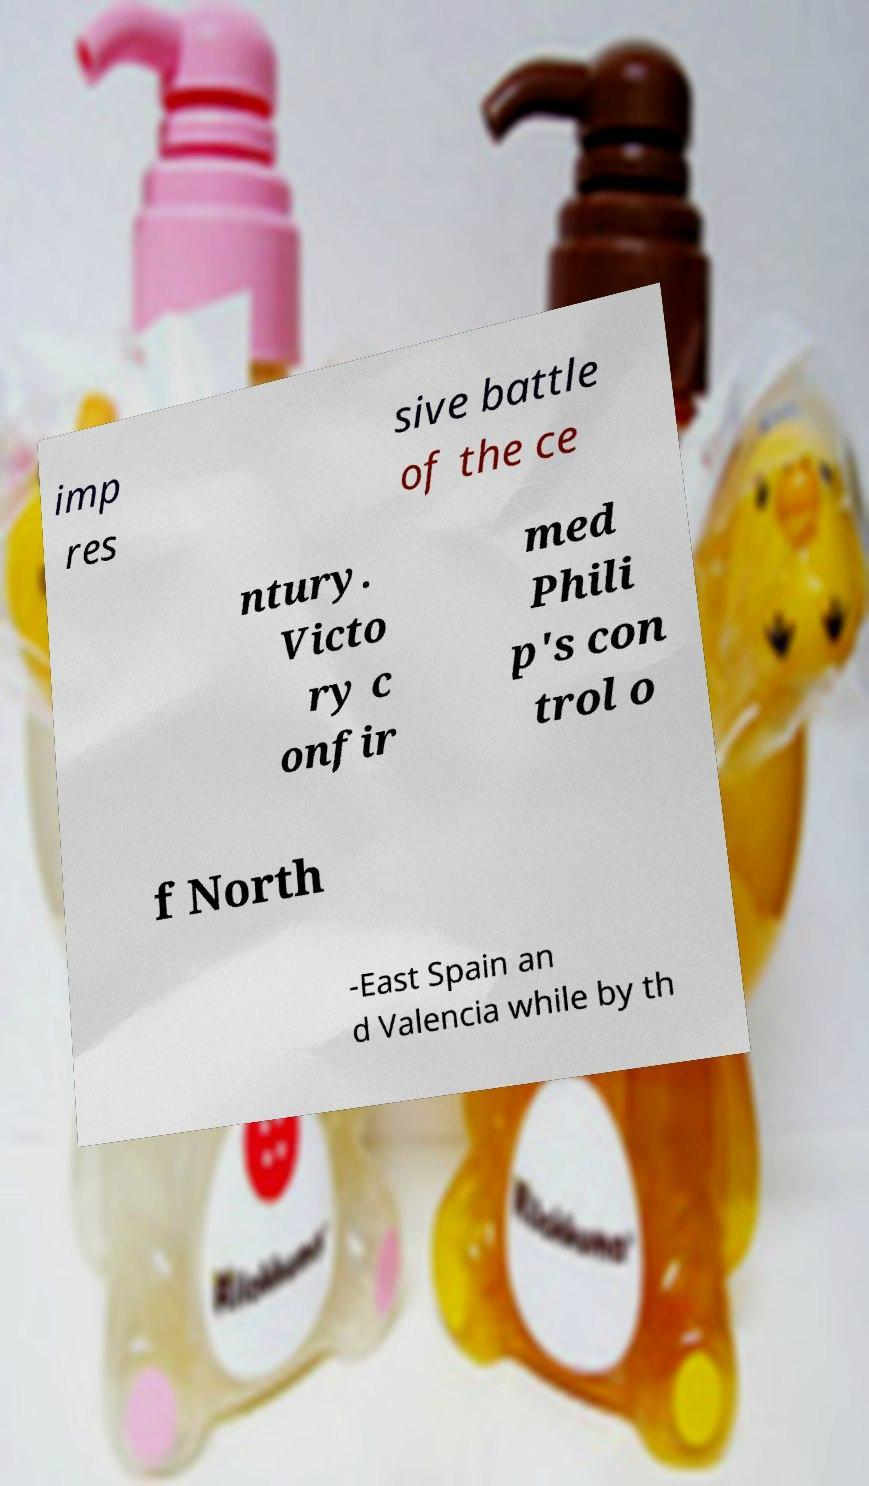Could you assist in decoding the text presented in this image and type it out clearly? imp res sive battle of the ce ntury. Victo ry c onfir med Phili p's con trol o f North -East Spain an d Valencia while by th 